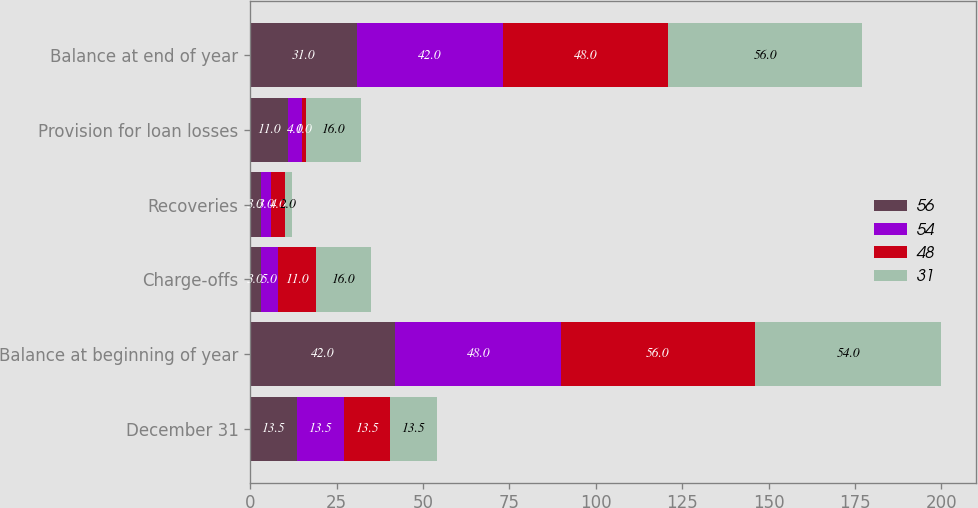Convert chart. <chart><loc_0><loc_0><loc_500><loc_500><stacked_bar_chart><ecel><fcel>December 31<fcel>Balance at beginning of year<fcel>Charge-offs<fcel>Recoveries<fcel>Provision for loan losses<fcel>Balance at end of year<nl><fcel>56<fcel>13.5<fcel>42<fcel>3<fcel>3<fcel>11<fcel>31<nl><fcel>54<fcel>13.5<fcel>48<fcel>5<fcel>3<fcel>4<fcel>42<nl><fcel>48<fcel>13.5<fcel>56<fcel>11<fcel>4<fcel>1<fcel>48<nl><fcel>31<fcel>13.5<fcel>54<fcel>16<fcel>2<fcel>16<fcel>56<nl></chart> 